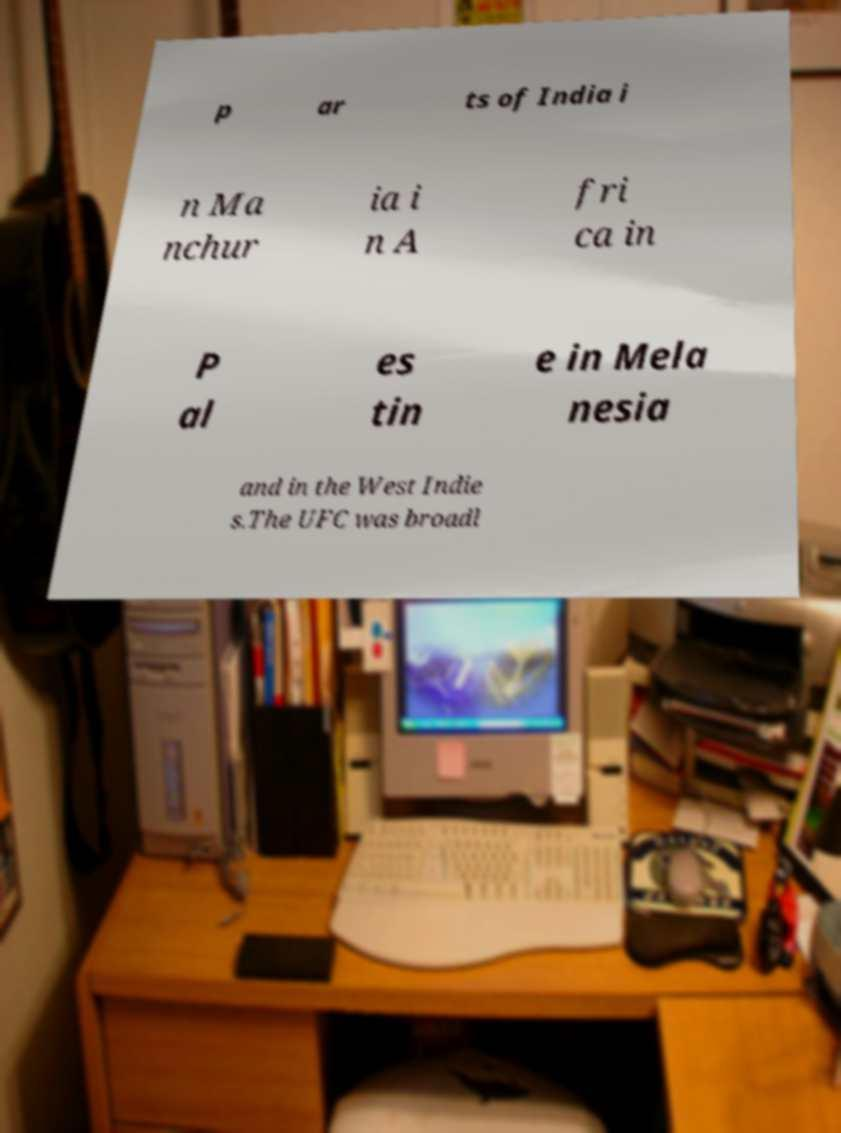Please read and relay the text visible in this image. What does it say? p ar ts of India i n Ma nchur ia i n A fri ca in P al es tin e in Mela nesia and in the West Indie s.The UFC was broadl 